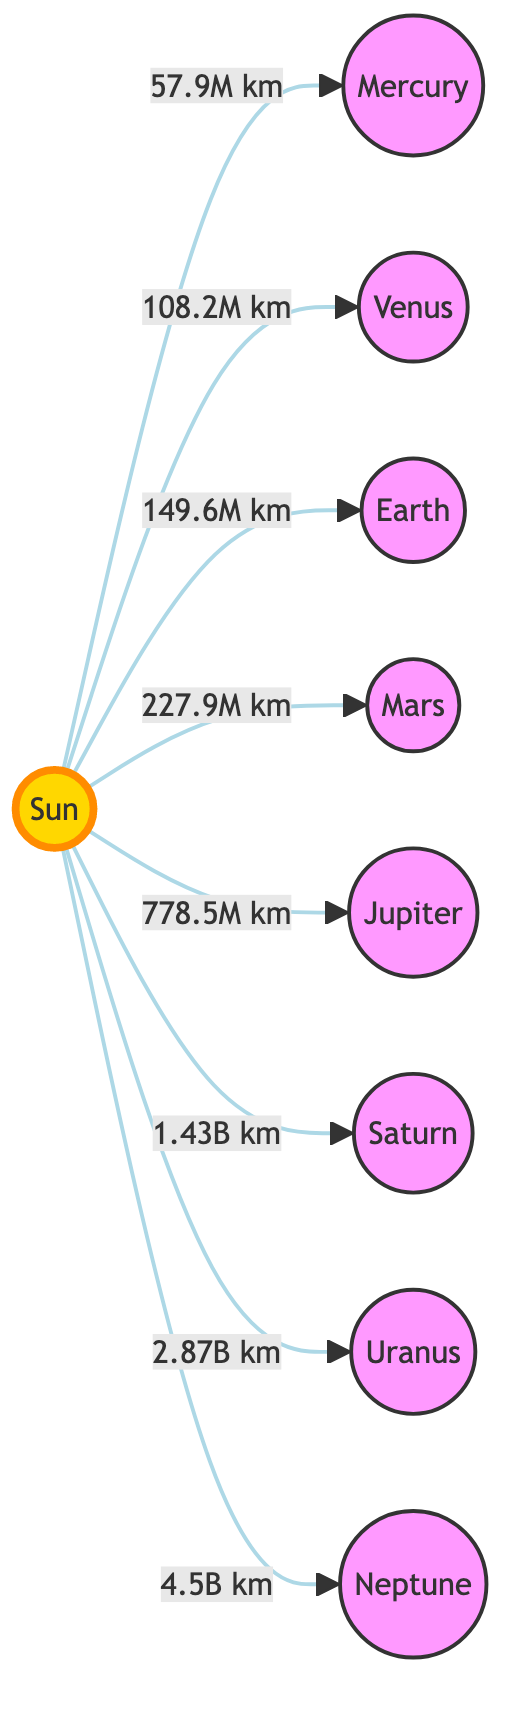What is the distance from the Sun to Earth? The diagram shows an arrow from the Sun to Earth labeled "149.6M km," which indicates the distance between these two objects.
Answer: 149.6M km What planet is closest to the Sun? The diagram features Mercury being directly connected to the Sun with an arrow, indicating it's the nearest planet.
Answer: Mercury How many planets are represented in the diagram? Upon counting the nodes connected to the Sun, there are a total of eight planets listed in the diagram.
Answer: 8 Which planet is farthest from the Sun? The diagram shows an arrow connecting the Sun to Neptune, which is the last planet listed, indicating it is the furthest from the Sun.
Answer: Neptune What is the distance from the Sun to Jupiter? The diagram includes an arrow labeled "778.5M km" leading from the Sun to Jupiter, indicating the distance.
Answer: 778.5M km What planet has a distance of 1.43 billion kilometers from the Sun? Referring to the arrow labeled "1.43B km," it connects the Sun to Saturn, indicating the distance to this planet.
Answer: Saturn Which planet is between Venus and Mars? The order of the planets listed in the diagram shows that Earth is located between Venus and Mars.
Answer: Earth What distance separates Saturn from the Sun? The diagram shows the distance from the Sun to Saturn labeled as "1.43B km." This is the direct information from the diagram.
Answer: 1.43B km Which two planets are found at distances less than 300 million kilometers from the Sun? By examining the distances labeled in the diagram, both Mercury (57.9M km) and Venus (108.2M km) are the only planets with distances under 300 million kilometers from the Sun.
Answer: Mercury, Venus 